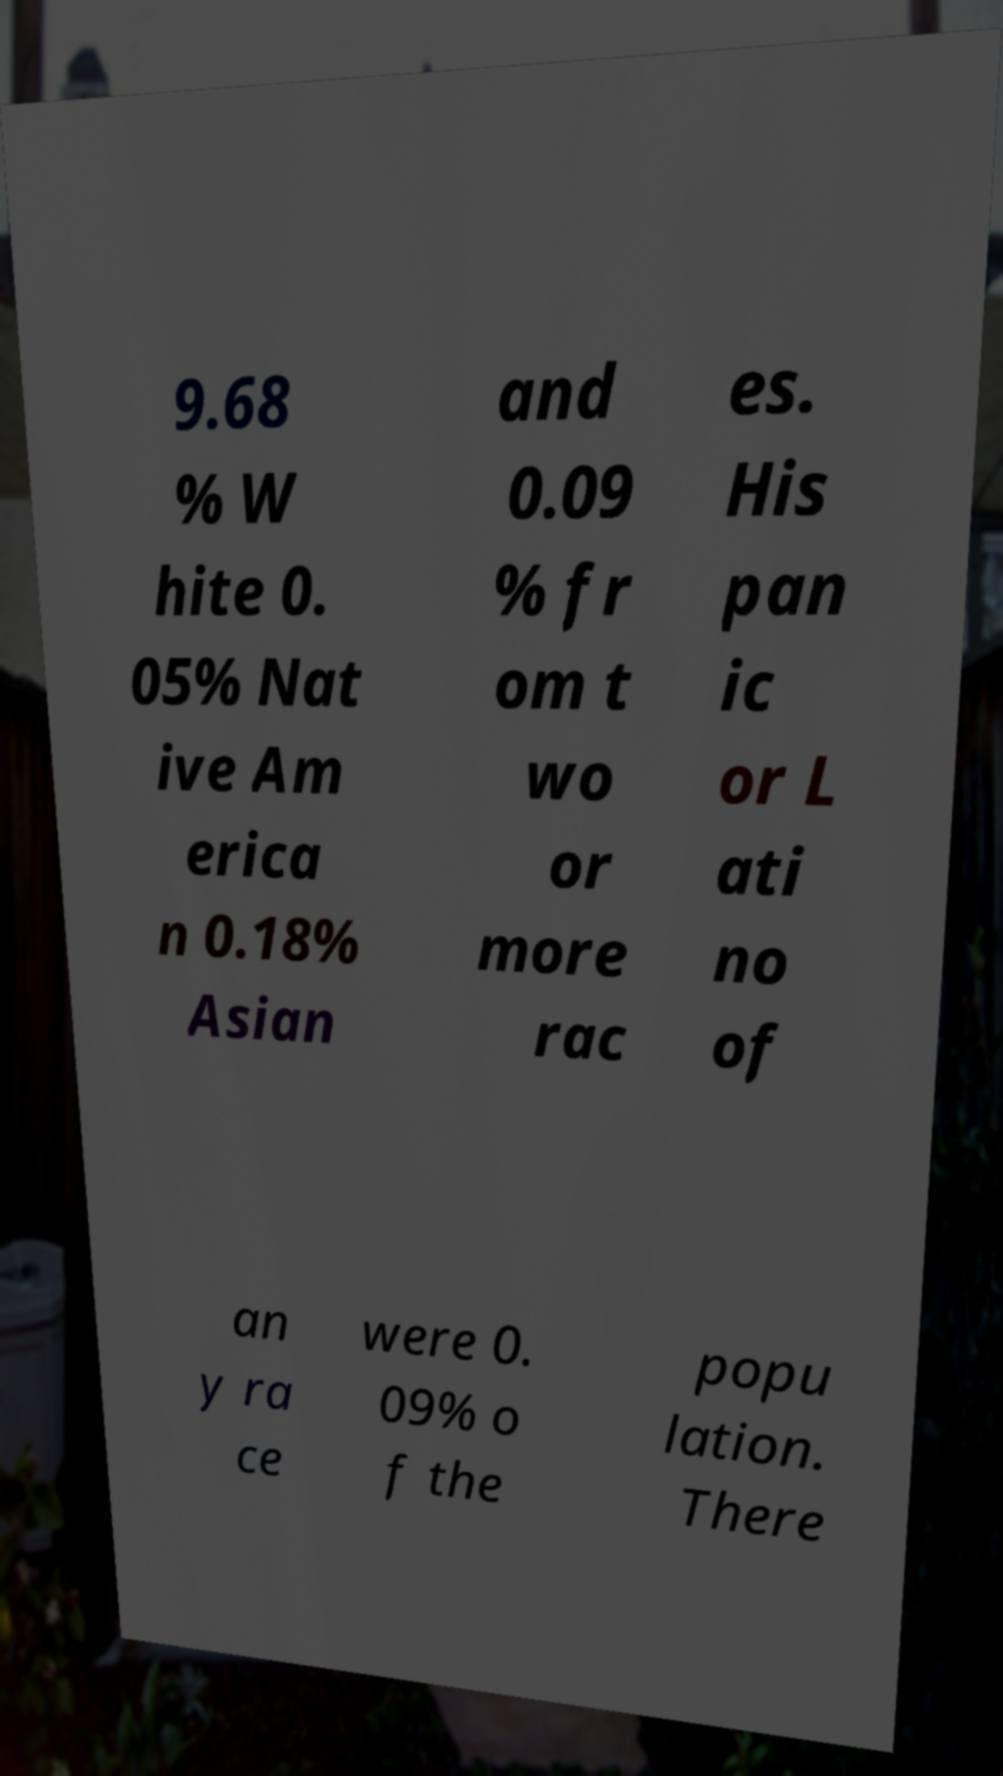Please identify and transcribe the text found in this image. 9.68 % W hite 0. 05% Nat ive Am erica n 0.18% Asian and 0.09 % fr om t wo or more rac es. His pan ic or L ati no of an y ra ce were 0. 09% o f the popu lation. There 